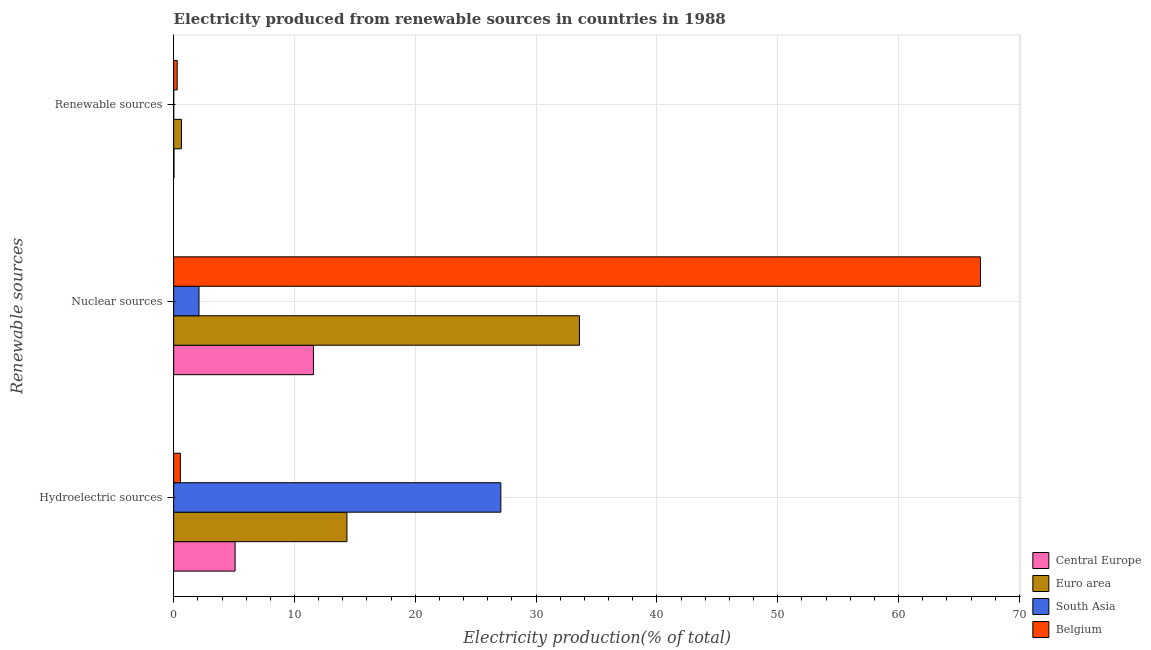How many different coloured bars are there?
Offer a very short reply. 4. How many groups of bars are there?
Your answer should be very brief. 3. How many bars are there on the 1st tick from the top?
Provide a short and direct response. 4. What is the label of the 3rd group of bars from the top?
Your response must be concise. Hydroelectric sources. What is the percentage of electricity produced by nuclear sources in Euro area?
Ensure brevity in your answer.  33.59. Across all countries, what is the maximum percentage of electricity produced by nuclear sources?
Your answer should be very brief. 66.78. Across all countries, what is the minimum percentage of electricity produced by hydroelectric sources?
Provide a short and direct response. 0.56. In which country was the percentage of electricity produced by renewable sources maximum?
Make the answer very short. Euro area. In which country was the percentage of electricity produced by nuclear sources minimum?
Your answer should be very brief. South Asia. What is the total percentage of electricity produced by nuclear sources in the graph?
Offer a very short reply. 114.04. What is the difference between the percentage of electricity produced by hydroelectric sources in South Asia and that in Belgium?
Your answer should be compact. 26.53. What is the difference between the percentage of electricity produced by nuclear sources in Belgium and the percentage of electricity produced by renewable sources in Euro area?
Make the answer very short. 66.14. What is the average percentage of electricity produced by hydroelectric sources per country?
Ensure brevity in your answer.  11.77. What is the difference between the percentage of electricity produced by hydroelectric sources and percentage of electricity produced by renewable sources in South Asia?
Offer a terse response. 27.08. In how many countries, is the percentage of electricity produced by hydroelectric sources greater than 54 %?
Your answer should be very brief. 0. What is the ratio of the percentage of electricity produced by nuclear sources in Belgium to that in Euro area?
Your response must be concise. 1.99. What is the difference between the highest and the second highest percentage of electricity produced by nuclear sources?
Keep it short and to the point. 33.19. What is the difference between the highest and the lowest percentage of electricity produced by nuclear sources?
Your answer should be compact. 64.69. Is the sum of the percentage of electricity produced by hydroelectric sources in Euro area and South Asia greater than the maximum percentage of electricity produced by renewable sources across all countries?
Keep it short and to the point. Yes. What does the 3rd bar from the top in Nuclear sources represents?
Your response must be concise. Euro area. What does the 3rd bar from the bottom in Hydroelectric sources represents?
Ensure brevity in your answer.  South Asia. Is it the case that in every country, the sum of the percentage of electricity produced by hydroelectric sources and percentage of electricity produced by nuclear sources is greater than the percentage of electricity produced by renewable sources?
Give a very brief answer. Yes. How many countries are there in the graph?
Your answer should be compact. 4. What is the difference between two consecutive major ticks on the X-axis?
Offer a very short reply. 10. Are the values on the major ticks of X-axis written in scientific E-notation?
Your response must be concise. No. Does the graph contain grids?
Keep it short and to the point. Yes. Where does the legend appear in the graph?
Ensure brevity in your answer.  Bottom right. What is the title of the graph?
Provide a short and direct response. Electricity produced from renewable sources in countries in 1988. What is the label or title of the Y-axis?
Offer a terse response. Renewable sources. What is the Electricity production(% of total) of Central Europe in Hydroelectric sources?
Keep it short and to the point. 5.08. What is the Electricity production(% of total) of Euro area in Hydroelectric sources?
Ensure brevity in your answer.  14.34. What is the Electricity production(% of total) of South Asia in Hydroelectric sources?
Keep it short and to the point. 27.08. What is the Electricity production(% of total) of Belgium in Hydroelectric sources?
Your answer should be compact. 0.56. What is the Electricity production(% of total) of Central Europe in Nuclear sources?
Ensure brevity in your answer.  11.57. What is the Electricity production(% of total) in Euro area in Nuclear sources?
Ensure brevity in your answer.  33.59. What is the Electricity production(% of total) in South Asia in Nuclear sources?
Your answer should be compact. 2.1. What is the Electricity production(% of total) in Belgium in Nuclear sources?
Your answer should be compact. 66.78. What is the Electricity production(% of total) in Central Europe in Renewable sources?
Offer a very short reply. 0.03. What is the Electricity production(% of total) of Euro area in Renewable sources?
Provide a succinct answer. 0.64. What is the Electricity production(% of total) in South Asia in Renewable sources?
Provide a succinct answer. 0. What is the Electricity production(% of total) of Belgium in Renewable sources?
Provide a succinct answer. 0.29. Across all Renewable sources, what is the maximum Electricity production(% of total) of Central Europe?
Your response must be concise. 11.57. Across all Renewable sources, what is the maximum Electricity production(% of total) in Euro area?
Keep it short and to the point. 33.59. Across all Renewable sources, what is the maximum Electricity production(% of total) in South Asia?
Your answer should be very brief. 27.08. Across all Renewable sources, what is the maximum Electricity production(% of total) of Belgium?
Make the answer very short. 66.78. Across all Renewable sources, what is the minimum Electricity production(% of total) of Central Europe?
Offer a very short reply. 0.03. Across all Renewable sources, what is the minimum Electricity production(% of total) of Euro area?
Keep it short and to the point. 0.64. Across all Renewable sources, what is the minimum Electricity production(% of total) of South Asia?
Give a very brief answer. 0. Across all Renewable sources, what is the minimum Electricity production(% of total) in Belgium?
Offer a terse response. 0.29. What is the total Electricity production(% of total) in Central Europe in the graph?
Offer a very short reply. 16.68. What is the total Electricity production(% of total) of Euro area in the graph?
Provide a short and direct response. 48.58. What is the total Electricity production(% of total) in South Asia in the graph?
Your response must be concise. 29.18. What is the total Electricity production(% of total) of Belgium in the graph?
Your response must be concise. 67.63. What is the difference between the Electricity production(% of total) in Central Europe in Hydroelectric sources and that in Nuclear sources?
Your answer should be compact. -6.48. What is the difference between the Electricity production(% of total) of Euro area in Hydroelectric sources and that in Nuclear sources?
Provide a short and direct response. -19.25. What is the difference between the Electricity production(% of total) in South Asia in Hydroelectric sources and that in Nuclear sources?
Your answer should be compact. 24.98. What is the difference between the Electricity production(% of total) in Belgium in Hydroelectric sources and that in Nuclear sources?
Ensure brevity in your answer.  -66.23. What is the difference between the Electricity production(% of total) of Central Europe in Hydroelectric sources and that in Renewable sources?
Make the answer very short. 5.06. What is the difference between the Electricity production(% of total) in Euro area in Hydroelectric sources and that in Renewable sources?
Offer a terse response. 13.7. What is the difference between the Electricity production(% of total) of South Asia in Hydroelectric sources and that in Renewable sources?
Provide a succinct answer. 27.08. What is the difference between the Electricity production(% of total) of Belgium in Hydroelectric sources and that in Renewable sources?
Give a very brief answer. 0.26. What is the difference between the Electricity production(% of total) in Central Europe in Nuclear sources and that in Renewable sources?
Provide a short and direct response. 11.54. What is the difference between the Electricity production(% of total) in Euro area in Nuclear sources and that in Renewable sources?
Give a very brief answer. 32.95. What is the difference between the Electricity production(% of total) of South Asia in Nuclear sources and that in Renewable sources?
Make the answer very short. 2.09. What is the difference between the Electricity production(% of total) in Belgium in Nuclear sources and that in Renewable sources?
Your answer should be compact. 66.49. What is the difference between the Electricity production(% of total) in Central Europe in Hydroelectric sources and the Electricity production(% of total) in Euro area in Nuclear sources?
Provide a short and direct response. -28.51. What is the difference between the Electricity production(% of total) of Central Europe in Hydroelectric sources and the Electricity production(% of total) of South Asia in Nuclear sources?
Your response must be concise. 2.99. What is the difference between the Electricity production(% of total) in Central Europe in Hydroelectric sources and the Electricity production(% of total) in Belgium in Nuclear sources?
Provide a short and direct response. -61.7. What is the difference between the Electricity production(% of total) in Euro area in Hydroelectric sources and the Electricity production(% of total) in South Asia in Nuclear sources?
Keep it short and to the point. 12.25. What is the difference between the Electricity production(% of total) in Euro area in Hydroelectric sources and the Electricity production(% of total) in Belgium in Nuclear sources?
Provide a short and direct response. -52.44. What is the difference between the Electricity production(% of total) of South Asia in Hydroelectric sources and the Electricity production(% of total) of Belgium in Nuclear sources?
Provide a succinct answer. -39.7. What is the difference between the Electricity production(% of total) of Central Europe in Hydroelectric sources and the Electricity production(% of total) of Euro area in Renewable sources?
Provide a succinct answer. 4.44. What is the difference between the Electricity production(% of total) of Central Europe in Hydroelectric sources and the Electricity production(% of total) of South Asia in Renewable sources?
Give a very brief answer. 5.08. What is the difference between the Electricity production(% of total) in Central Europe in Hydroelectric sources and the Electricity production(% of total) in Belgium in Renewable sources?
Your answer should be compact. 4.79. What is the difference between the Electricity production(% of total) of Euro area in Hydroelectric sources and the Electricity production(% of total) of South Asia in Renewable sources?
Your response must be concise. 14.34. What is the difference between the Electricity production(% of total) in Euro area in Hydroelectric sources and the Electricity production(% of total) in Belgium in Renewable sources?
Make the answer very short. 14.05. What is the difference between the Electricity production(% of total) in South Asia in Hydroelectric sources and the Electricity production(% of total) in Belgium in Renewable sources?
Keep it short and to the point. 26.79. What is the difference between the Electricity production(% of total) in Central Europe in Nuclear sources and the Electricity production(% of total) in Euro area in Renewable sources?
Ensure brevity in your answer.  10.93. What is the difference between the Electricity production(% of total) of Central Europe in Nuclear sources and the Electricity production(% of total) of South Asia in Renewable sources?
Your response must be concise. 11.57. What is the difference between the Electricity production(% of total) of Central Europe in Nuclear sources and the Electricity production(% of total) of Belgium in Renewable sources?
Make the answer very short. 11.28. What is the difference between the Electricity production(% of total) in Euro area in Nuclear sources and the Electricity production(% of total) in South Asia in Renewable sources?
Ensure brevity in your answer.  33.59. What is the difference between the Electricity production(% of total) of Euro area in Nuclear sources and the Electricity production(% of total) of Belgium in Renewable sources?
Your response must be concise. 33.3. What is the difference between the Electricity production(% of total) of South Asia in Nuclear sources and the Electricity production(% of total) of Belgium in Renewable sources?
Your response must be concise. 1.81. What is the average Electricity production(% of total) in Central Europe per Renewable sources?
Provide a short and direct response. 5.56. What is the average Electricity production(% of total) in Euro area per Renewable sources?
Your answer should be very brief. 16.19. What is the average Electricity production(% of total) in South Asia per Renewable sources?
Provide a succinct answer. 9.73. What is the average Electricity production(% of total) of Belgium per Renewable sources?
Offer a terse response. 22.54. What is the difference between the Electricity production(% of total) of Central Europe and Electricity production(% of total) of Euro area in Hydroelectric sources?
Offer a very short reply. -9.26. What is the difference between the Electricity production(% of total) in Central Europe and Electricity production(% of total) in South Asia in Hydroelectric sources?
Provide a succinct answer. -22. What is the difference between the Electricity production(% of total) in Central Europe and Electricity production(% of total) in Belgium in Hydroelectric sources?
Offer a very short reply. 4.53. What is the difference between the Electricity production(% of total) in Euro area and Electricity production(% of total) in South Asia in Hydroelectric sources?
Give a very brief answer. -12.74. What is the difference between the Electricity production(% of total) in Euro area and Electricity production(% of total) in Belgium in Hydroelectric sources?
Offer a very short reply. 13.79. What is the difference between the Electricity production(% of total) in South Asia and Electricity production(% of total) in Belgium in Hydroelectric sources?
Your answer should be very brief. 26.53. What is the difference between the Electricity production(% of total) in Central Europe and Electricity production(% of total) in Euro area in Nuclear sources?
Give a very brief answer. -22.02. What is the difference between the Electricity production(% of total) of Central Europe and Electricity production(% of total) of South Asia in Nuclear sources?
Provide a short and direct response. 9.47. What is the difference between the Electricity production(% of total) in Central Europe and Electricity production(% of total) in Belgium in Nuclear sources?
Your answer should be compact. -55.21. What is the difference between the Electricity production(% of total) of Euro area and Electricity production(% of total) of South Asia in Nuclear sources?
Keep it short and to the point. 31.5. What is the difference between the Electricity production(% of total) of Euro area and Electricity production(% of total) of Belgium in Nuclear sources?
Provide a short and direct response. -33.19. What is the difference between the Electricity production(% of total) in South Asia and Electricity production(% of total) in Belgium in Nuclear sources?
Ensure brevity in your answer.  -64.69. What is the difference between the Electricity production(% of total) of Central Europe and Electricity production(% of total) of Euro area in Renewable sources?
Ensure brevity in your answer.  -0.62. What is the difference between the Electricity production(% of total) in Central Europe and Electricity production(% of total) in South Asia in Renewable sources?
Keep it short and to the point. 0.02. What is the difference between the Electricity production(% of total) of Central Europe and Electricity production(% of total) of Belgium in Renewable sources?
Offer a very short reply. -0.27. What is the difference between the Electricity production(% of total) of Euro area and Electricity production(% of total) of South Asia in Renewable sources?
Give a very brief answer. 0.64. What is the difference between the Electricity production(% of total) of Euro area and Electricity production(% of total) of Belgium in Renewable sources?
Provide a short and direct response. 0.35. What is the difference between the Electricity production(% of total) of South Asia and Electricity production(% of total) of Belgium in Renewable sources?
Your answer should be very brief. -0.29. What is the ratio of the Electricity production(% of total) of Central Europe in Hydroelectric sources to that in Nuclear sources?
Offer a terse response. 0.44. What is the ratio of the Electricity production(% of total) of Euro area in Hydroelectric sources to that in Nuclear sources?
Provide a succinct answer. 0.43. What is the ratio of the Electricity production(% of total) in South Asia in Hydroelectric sources to that in Nuclear sources?
Offer a terse response. 12.92. What is the ratio of the Electricity production(% of total) in Belgium in Hydroelectric sources to that in Nuclear sources?
Provide a short and direct response. 0.01. What is the ratio of the Electricity production(% of total) in Central Europe in Hydroelectric sources to that in Renewable sources?
Your answer should be very brief. 199.9. What is the ratio of the Electricity production(% of total) of Euro area in Hydroelectric sources to that in Renewable sources?
Make the answer very short. 22.31. What is the ratio of the Electricity production(% of total) in South Asia in Hydroelectric sources to that in Renewable sources?
Make the answer very short. 1.31e+04. What is the ratio of the Electricity production(% of total) of Belgium in Hydroelectric sources to that in Renewable sources?
Offer a terse response. 1.91. What is the ratio of the Electricity production(% of total) in Central Europe in Nuclear sources to that in Renewable sources?
Provide a succinct answer. 454.87. What is the ratio of the Electricity production(% of total) in Euro area in Nuclear sources to that in Renewable sources?
Give a very brief answer. 52.25. What is the ratio of the Electricity production(% of total) of South Asia in Nuclear sources to that in Renewable sources?
Make the answer very short. 1011.83. What is the ratio of the Electricity production(% of total) of Belgium in Nuclear sources to that in Renewable sources?
Ensure brevity in your answer.  229.27. What is the difference between the highest and the second highest Electricity production(% of total) of Central Europe?
Your answer should be very brief. 6.48. What is the difference between the highest and the second highest Electricity production(% of total) of Euro area?
Your answer should be very brief. 19.25. What is the difference between the highest and the second highest Electricity production(% of total) of South Asia?
Offer a terse response. 24.98. What is the difference between the highest and the second highest Electricity production(% of total) in Belgium?
Provide a short and direct response. 66.23. What is the difference between the highest and the lowest Electricity production(% of total) in Central Europe?
Keep it short and to the point. 11.54. What is the difference between the highest and the lowest Electricity production(% of total) of Euro area?
Give a very brief answer. 32.95. What is the difference between the highest and the lowest Electricity production(% of total) of South Asia?
Keep it short and to the point. 27.08. What is the difference between the highest and the lowest Electricity production(% of total) in Belgium?
Ensure brevity in your answer.  66.49. 